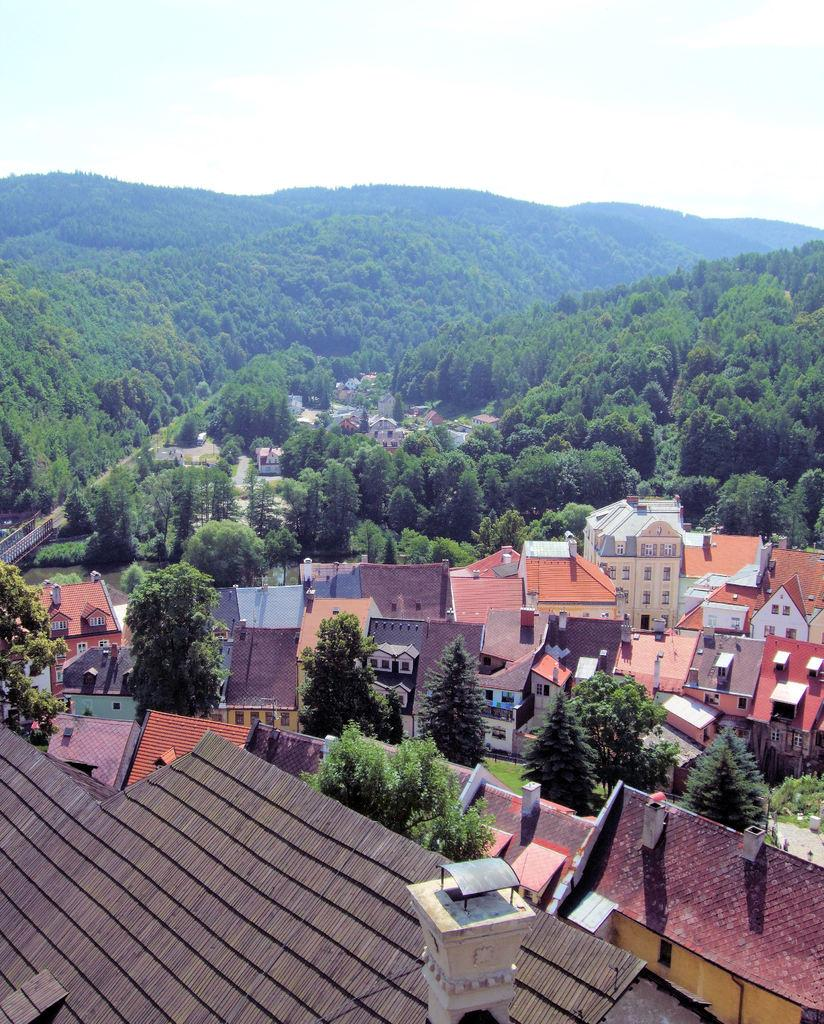What type of structures can be seen in the image? There are houses in the image. What connects the two sides of the image? There is a bridge in the image. What type of vegetation is present in the image? There are trees in the image. What is visible above the structures and vegetation? The sky is visible in the image. Where is the button located in the image? There is no button present in the image. What color is the tongue of the tree in the image? There is no tongue associated with the trees in the image, as trees do not have tongues. 